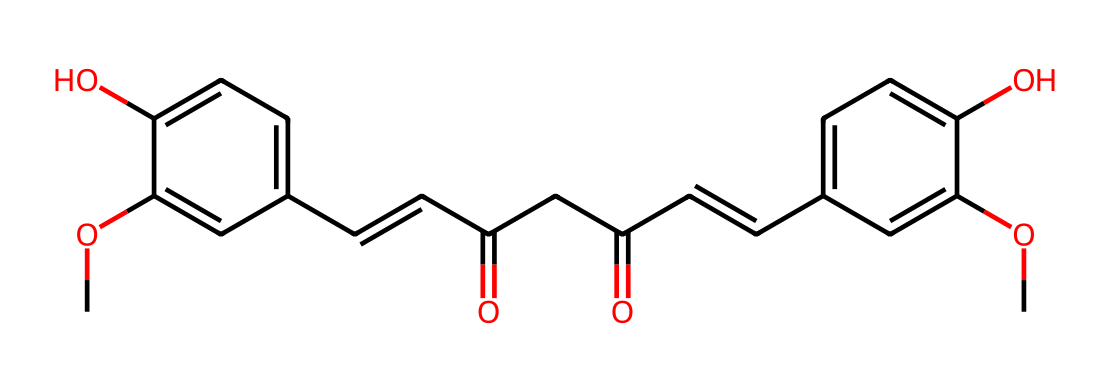What is the molecular formula of curcumin based on the SMILES provided? To derive the molecular formula from the SMILES, the representation indicates that there are 21 carbon (C) atoms, 20 hydrogen (H) atoms, and 6 oxygen (O) atoms in total. Therefore, adding them up gives us C21H20O6.
Answer: C21H20O6 How many hydroxyl groups (-OH) are present in curcumin? Upon inspecting the structure derived from the SMILES, there are two -OH groups visible attached to benzene rings.
Answer: 2 What functional groups can be identified in curcumin's structure? The SMILES indicates the presence of hydroxyl (-OH) and carbonyl (C=O) functional groups, as well as conjugated double bonds (alkenes) in the structure.
Answer: hydroxyl, carbonyl, alkenes Which part of curcumin contributes to its antioxidant properties? The conjugation of double bonds and the presence of hydroxyl groups enhance electron donation capabilities, providing strong antioxidant activity. The specific structural features that promote this are the -OH groups and conjugated systems.
Answer: -OH groups, conjugated system What is the total number of rings present in the curcumin molecule? The SMILES structure shows two aromatic rings, which are characterized by a cyclic arrangement of carbon atoms with alternating double bonds; thus, the total is two rings.
Answer: 2 How many double bonds are in the curcumin structure? Analyzing the SMILES, we count four double bonds in the chemical structure, including those in the rings and the double bonds in the alkene portions.
Answer: 4 